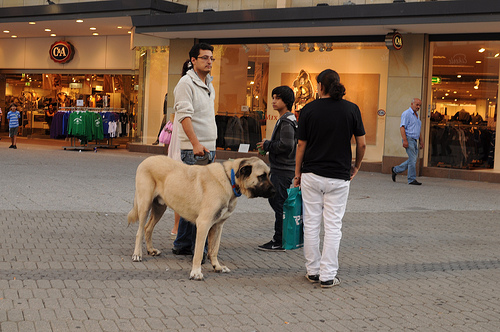What is the animal to the left of the child that is in the middle? The animal to the left of the child positioned in the middle of the scene is a large dog, adding to the dynamics of the group. 